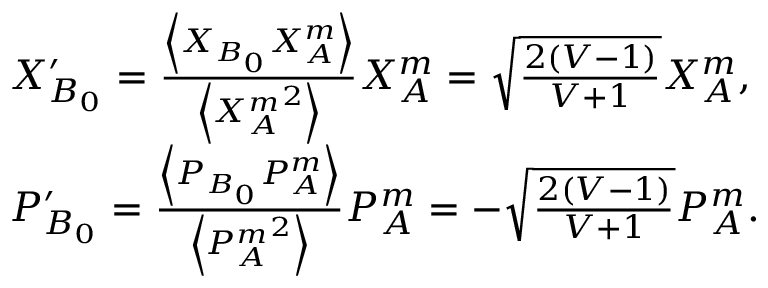<formula> <loc_0><loc_0><loc_500><loc_500>\begin{array} { r l } & { X _ { B _ { 0 } } ^ { \prime } = \frac { \left \langle { { X } _ { B _ { 0 } } } { { X } _ { A } ^ { m } } \right \rangle } { \left \langle { { X } _ { A } ^ { m } } ^ { 2 } \right \rangle } { { X } _ { A } ^ { m } } = \sqrt { \frac { 2 ( V - 1 ) } { V + 1 } } { { X } _ { A } ^ { m } } , } \\ & { P _ { B _ { 0 } } ^ { \prime } = \frac { \left \langle { { P } _ { B _ { 0 } } } { { P } _ { A } ^ { m } } \right \rangle } { \left \langle { { P } _ { A } ^ { m } } ^ { 2 } \right \rangle } { { P } _ { A } ^ { m } } = - \sqrt { \frac { 2 ( V - 1 ) } { V + 1 } } { { P } _ { A } ^ { m } } . } \end{array}</formula> 